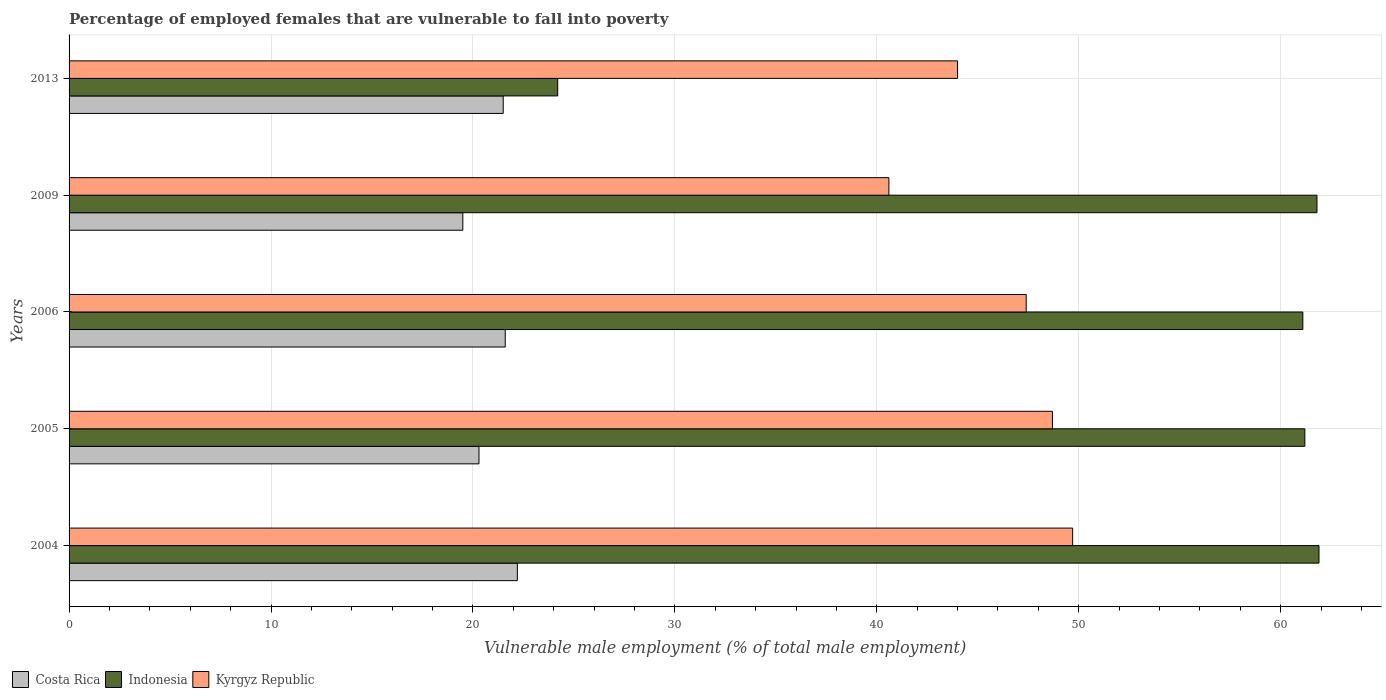How many different coloured bars are there?
Give a very brief answer. 3. Are the number of bars per tick equal to the number of legend labels?
Keep it short and to the point. Yes. What is the label of the 5th group of bars from the top?
Make the answer very short. 2004. What is the percentage of employed females who are vulnerable to fall into poverty in Costa Rica in 2013?
Your answer should be compact. 21.5. Across all years, what is the maximum percentage of employed females who are vulnerable to fall into poverty in Kyrgyz Republic?
Keep it short and to the point. 49.7. Across all years, what is the minimum percentage of employed females who are vulnerable to fall into poverty in Costa Rica?
Your answer should be very brief. 19.5. What is the total percentage of employed females who are vulnerable to fall into poverty in Costa Rica in the graph?
Offer a terse response. 105.1. What is the difference between the percentage of employed females who are vulnerable to fall into poverty in Costa Rica in 2004 and that in 2006?
Offer a terse response. 0.6. What is the difference between the percentage of employed females who are vulnerable to fall into poverty in Indonesia in 2006 and the percentage of employed females who are vulnerable to fall into poverty in Kyrgyz Republic in 2013?
Offer a terse response. 17.1. What is the average percentage of employed females who are vulnerable to fall into poverty in Costa Rica per year?
Ensure brevity in your answer.  21.02. In the year 2006, what is the difference between the percentage of employed females who are vulnerable to fall into poverty in Kyrgyz Republic and percentage of employed females who are vulnerable to fall into poverty in Indonesia?
Make the answer very short. -13.7. In how many years, is the percentage of employed females who are vulnerable to fall into poverty in Costa Rica greater than 2 %?
Your response must be concise. 5. What is the ratio of the percentage of employed females who are vulnerable to fall into poverty in Indonesia in 2005 to that in 2006?
Give a very brief answer. 1. Is the difference between the percentage of employed females who are vulnerable to fall into poverty in Kyrgyz Republic in 2004 and 2013 greater than the difference between the percentage of employed females who are vulnerable to fall into poverty in Indonesia in 2004 and 2013?
Provide a succinct answer. No. What is the difference between the highest and the second highest percentage of employed females who are vulnerable to fall into poverty in Costa Rica?
Offer a very short reply. 0.6. What is the difference between the highest and the lowest percentage of employed females who are vulnerable to fall into poverty in Indonesia?
Keep it short and to the point. 37.7. In how many years, is the percentage of employed females who are vulnerable to fall into poverty in Kyrgyz Republic greater than the average percentage of employed females who are vulnerable to fall into poverty in Kyrgyz Republic taken over all years?
Your answer should be very brief. 3. Is the sum of the percentage of employed females who are vulnerable to fall into poverty in Costa Rica in 2006 and 2013 greater than the maximum percentage of employed females who are vulnerable to fall into poverty in Indonesia across all years?
Your answer should be very brief. No. Is it the case that in every year, the sum of the percentage of employed females who are vulnerable to fall into poverty in Costa Rica and percentage of employed females who are vulnerable to fall into poverty in Kyrgyz Republic is greater than the percentage of employed females who are vulnerable to fall into poverty in Indonesia?
Your answer should be very brief. No. Are all the bars in the graph horizontal?
Keep it short and to the point. Yes. Does the graph contain any zero values?
Your response must be concise. No. Does the graph contain grids?
Make the answer very short. Yes. Where does the legend appear in the graph?
Your response must be concise. Bottom left. What is the title of the graph?
Provide a succinct answer. Percentage of employed females that are vulnerable to fall into poverty. What is the label or title of the X-axis?
Give a very brief answer. Vulnerable male employment (% of total male employment). What is the label or title of the Y-axis?
Provide a succinct answer. Years. What is the Vulnerable male employment (% of total male employment) of Costa Rica in 2004?
Your response must be concise. 22.2. What is the Vulnerable male employment (% of total male employment) in Indonesia in 2004?
Your response must be concise. 61.9. What is the Vulnerable male employment (% of total male employment) in Kyrgyz Republic in 2004?
Your answer should be compact. 49.7. What is the Vulnerable male employment (% of total male employment) of Costa Rica in 2005?
Keep it short and to the point. 20.3. What is the Vulnerable male employment (% of total male employment) of Indonesia in 2005?
Your answer should be compact. 61.2. What is the Vulnerable male employment (% of total male employment) in Kyrgyz Republic in 2005?
Your answer should be very brief. 48.7. What is the Vulnerable male employment (% of total male employment) in Costa Rica in 2006?
Ensure brevity in your answer.  21.6. What is the Vulnerable male employment (% of total male employment) in Indonesia in 2006?
Your answer should be compact. 61.1. What is the Vulnerable male employment (% of total male employment) in Kyrgyz Republic in 2006?
Your answer should be compact. 47.4. What is the Vulnerable male employment (% of total male employment) in Costa Rica in 2009?
Provide a succinct answer. 19.5. What is the Vulnerable male employment (% of total male employment) of Indonesia in 2009?
Provide a succinct answer. 61.8. What is the Vulnerable male employment (% of total male employment) of Kyrgyz Republic in 2009?
Provide a succinct answer. 40.6. What is the Vulnerable male employment (% of total male employment) in Indonesia in 2013?
Offer a very short reply. 24.2. What is the Vulnerable male employment (% of total male employment) of Kyrgyz Republic in 2013?
Make the answer very short. 44. Across all years, what is the maximum Vulnerable male employment (% of total male employment) in Costa Rica?
Offer a terse response. 22.2. Across all years, what is the maximum Vulnerable male employment (% of total male employment) of Indonesia?
Offer a very short reply. 61.9. Across all years, what is the maximum Vulnerable male employment (% of total male employment) of Kyrgyz Republic?
Provide a succinct answer. 49.7. Across all years, what is the minimum Vulnerable male employment (% of total male employment) in Indonesia?
Your answer should be compact. 24.2. Across all years, what is the minimum Vulnerable male employment (% of total male employment) in Kyrgyz Republic?
Offer a terse response. 40.6. What is the total Vulnerable male employment (% of total male employment) of Costa Rica in the graph?
Your answer should be compact. 105.1. What is the total Vulnerable male employment (% of total male employment) in Indonesia in the graph?
Offer a very short reply. 270.2. What is the total Vulnerable male employment (% of total male employment) in Kyrgyz Republic in the graph?
Your answer should be compact. 230.4. What is the difference between the Vulnerable male employment (% of total male employment) in Indonesia in 2004 and that in 2005?
Make the answer very short. 0.7. What is the difference between the Vulnerable male employment (% of total male employment) in Costa Rica in 2004 and that in 2006?
Your answer should be very brief. 0.6. What is the difference between the Vulnerable male employment (% of total male employment) in Kyrgyz Republic in 2004 and that in 2006?
Give a very brief answer. 2.3. What is the difference between the Vulnerable male employment (% of total male employment) in Costa Rica in 2004 and that in 2009?
Offer a very short reply. 2.7. What is the difference between the Vulnerable male employment (% of total male employment) in Indonesia in 2004 and that in 2009?
Provide a succinct answer. 0.1. What is the difference between the Vulnerable male employment (% of total male employment) in Costa Rica in 2004 and that in 2013?
Provide a succinct answer. 0.7. What is the difference between the Vulnerable male employment (% of total male employment) in Indonesia in 2004 and that in 2013?
Make the answer very short. 37.7. What is the difference between the Vulnerable male employment (% of total male employment) of Kyrgyz Republic in 2004 and that in 2013?
Provide a short and direct response. 5.7. What is the difference between the Vulnerable male employment (% of total male employment) in Indonesia in 2005 and that in 2006?
Ensure brevity in your answer.  0.1. What is the difference between the Vulnerable male employment (% of total male employment) in Kyrgyz Republic in 2005 and that in 2009?
Provide a short and direct response. 8.1. What is the difference between the Vulnerable male employment (% of total male employment) of Indonesia in 2005 and that in 2013?
Ensure brevity in your answer.  37. What is the difference between the Vulnerable male employment (% of total male employment) in Indonesia in 2006 and that in 2009?
Your response must be concise. -0.7. What is the difference between the Vulnerable male employment (% of total male employment) in Costa Rica in 2006 and that in 2013?
Keep it short and to the point. 0.1. What is the difference between the Vulnerable male employment (% of total male employment) in Indonesia in 2006 and that in 2013?
Make the answer very short. 36.9. What is the difference between the Vulnerable male employment (% of total male employment) in Kyrgyz Republic in 2006 and that in 2013?
Provide a short and direct response. 3.4. What is the difference between the Vulnerable male employment (% of total male employment) in Costa Rica in 2009 and that in 2013?
Give a very brief answer. -2. What is the difference between the Vulnerable male employment (% of total male employment) in Indonesia in 2009 and that in 2013?
Offer a very short reply. 37.6. What is the difference between the Vulnerable male employment (% of total male employment) in Costa Rica in 2004 and the Vulnerable male employment (% of total male employment) in Indonesia in 2005?
Your response must be concise. -39. What is the difference between the Vulnerable male employment (% of total male employment) in Costa Rica in 2004 and the Vulnerable male employment (% of total male employment) in Kyrgyz Republic in 2005?
Your answer should be compact. -26.5. What is the difference between the Vulnerable male employment (% of total male employment) in Indonesia in 2004 and the Vulnerable male employment (% of total male employment) in Kyrgyz Republic in 2005?
Your answer should be compact. 13.2. What is the difference between the Vulnerable male employment (% of total male employment) in Costa Rica in 2004 and the Vulnerable male employment (% of total male employment) in Indonesia in 2006?
Your answer should be very brief. -38.9. What is the difference between the Vulnerable male employment (% of total male employment) of Costa Rica in 2004 and the Vulnerable male employment (% of total male employment) of Kyrgyz Republic in 2006?
Provide a succinct answer. -25.2. What is the difference between the Vulnerable male employment (% of total male employment) in Indonesia in 2004 and the Vulnerable male employment (% of total male employment) in Kyrgyz Republic in 2006?
Provide a short and direct response. 14.5. What is the difference between the Vulnerable male employment (% of total male employment) of Costa Rica in 2004 and the Vulnerable male employment (% of total male employment) of Indonesia in 2009?
Give a very brief answer. -39.6. What is the difference between the Vulnerable male employment (% of total male employment) in Costa Rica in 2004 and the Vulnerable male employment (% of total male employment) in Kyrgyz Republic in 2009?
Make the answer very short. -18.4. What is the difference between the Vulnerable male employment (% of total male employment) of Indonesia in 2004 and the Vulnerable male employment (% of total male employment) of Kyrgyz Republic in 2009?
Offer a very short reply. 21.3. What is the difference between the Vulnerable male employment (% of total male employment) of Costa Rica in 2004 and the Vulnerable male employment (% of total male employment) of Kyrgyz Republic in 2013?
Your answer should be compact. -21.8. What is the difference between the Vulnerable male employment (% of total male employment) of Costa Rica in 2005 and the Vulnerable male employment (% of total male employment) of Indonesia in 2006?
Offer a terse response. -40.8. What is the difference between the Vulnerable male employment (% of total male employment) of Costa Rica in 2005 and the Vulnerable male employment (% of total male employment) of Kyrgyz Republic in 2006?
Give a very brief answer. -27.1. What is the difference between the Vulnerable male employment (% of total male employment) in Costa Rica in 2005 and the Vulnerable male employment (% of total male employment) in Indonesia in 2009?
Make the answer very short. -41.5. What is the difference between the Vulnerable male employment (% of total male employment) of Costa Rica in 2005 and the Vulnerable male employment (% of total male employment) of Kyrgyz Republic in 2009?
Make the answer very short. -20.3. What is the difference between the Vulnerable male employment (% of total male employment) in Indonesia in 2005 and the Vulnerable male employment (% of total male employment) in Kyrgyz Republic in 2009?
Your response must be concise. 20.6. What is the difference between the Vulnerable male employment (% of total male employment) in Costa Rica in 2005 and the Vulnerable male employment (% of total male employment) in Indonesia in 2013?
Your answer should be very brief. -3.9. What is the difference between the Vulnerable male employment (% of total male employment) in Costa Rica in 2005 and the Vulnerable male employment (% of total male employment) in Kyrgyz Republic in 2013?
Your response must be concise. -23.7. What is the difference between the Vulnerable male employment (% of total male employment) in Indonesia in 2005 and the Vulnerable male employment (% of total male employment) in Kyrgyz Republic in 2013?
Keep it short and to the point. 17.2. What is the difference between the Vulnerable male employment (% of total male employment) of Costa Rica in 2006 and the Vulnerable male employment (% of total male employment) of Indonesia in 2009?
Offer a very short reply. -40.2. What is the difference between the Vulnerable male employment (% of total male employment) of Costa Rica in 2006 and the Vulnerable male employment (% of total male employment) of Kyrgyz Republic in 2013?
Make the answer very short. -22.4. What is the difference between the Vulnerable male employment (% of total male employment) in Indonesia in 2006 and the Vulnerable male employment (% of total male employment) in Kyrgyz Republic in 2013?
Keep it short and to the point. 17.1. What is the difference between the Vulnerable male employment (% of total male employment) in Costa Rica in 2009 and the Vulnerable male employment (% of total male employment) in Indonesia in 2013?
Your response must be concise. -4.7. What is the difference between the Vulnerable male employment (% of total male employment) in Costa Rica in 2009 and the Vulnerable male employment (% of total male employment) in Kyrgyz Republic in 2013?
Provide a short and direct response. -24.5. What is the average Vulnerable male employment (% of total male employment) of Costa Rica per year?
Your response must be concise. 21.02. What is the average Vulnerable male employment (% of total male employment) of Indonesia per year?
Offer a very short reply. 54.04. What is the average Vulnerable male employment (% of total male employment) in Kyrgyz Republic per year?
Keep it short and to the point. 46.08. In the year 2004, what is the difference between the Vulnerable male employment (% of total male employment) of Costa Rica and Vulnerable male employment (% of total male employment) of Indonesia?
Provide a short and direct response. -39.7. In the year 2004, what is the difference between the Vulnerable male employment (% of total male employment) in Costa Rica and Vulnerable male employment (% of total male employment) in Kyrgyz Republic?
Offer a very short reply. -27.5. In the year 2004, what is the difference between the Vulnerable male employment (% of total male employment) of Indonesia and Vulnerable male employment (% of total male employment) of Kyrgyz Republic?
Offer a terse response. 12.2. In the year 2005, what is the difference between the Vulnerable male employment (% of total male employment) in Costa Rica and Vulnerable male employment (% of total male employment) in Indonesia?
Your answer should be very brief. -40.9. In the year 2005, what is the difference between the Vulnerable male employment (% of total male employment) in Costa Rica and Vulnerable male employment (% of total male employment) in Kyrgyz Republic?
Provide a short and direct response. -28.4. In the year 2006, what is the difference between the Vulnerable male employment (% of total male employment) of Costa Rica and Vulnerable male employment (% of total male employment) of Indonesia?
Your answer should be compact. -39.5. In the year 2006, what is the difference between the Vulnerable male employment (% of total male employment) of Costa Rica and Vulnerable male employment (% of total male employment) of Kyrgyz Republic?
Give a very brief answer. -25.8. In the year 2009, what is the difference between the Vulnerable male employment (% of total male employment) of Costa Rica and Vulnerable male employment (% of total male employment) of Indonesia?
Your response must be concise. -42.3. In the year 2009, what is the difference between the Vulnerable male employment (% of total male employment) of Costa Rica and Vulnerable male employment (% of total male employment) of Kyrgyz Republic?
Provide a succinct answer. -21.1. In the year 2009, what is the difference between the Vulnerable male employment (% of total male employment) of Indonesia and Vulnerable male employment (% of total male employment) of Kyrgyz Republic?
Keep it short and to the point. 21.2. In the year 2013, what is the difference between the Vulnerable male employment (% of total male employment) of Costa Rica and Vulnerable male employment (% of total male employment) of Indonesia?
Offer a very short reply. -2.7. In the year 2013, what is the difference between the Vulnerable male employment (% of total male employment) of Costa Rica and Vulnerable male employment (% of total male employment) of Kyrgyz Republic?
Your answer should be very brief. -22.5. In the year 2013, what is the difference between the Vulnerable male employment (% of total male employment) in Indonesia and Vulnerable male employment (% of total male employment) in Kyrgyz Republic?
Make the answer very short. -19.8. What is the ratio of the Vulnerable male employment (% of total male employment) of Costa Rica in 2004 to that in 2005?
Provide a succinct answer. 1.09. What is the ratio of the Vulnerable male employment (% of total male employment) in Indonesia in 2004 to that in 2005?
Your answer should be very brief. 1.01. What is the ratio of the Vulnerable male employment (% of total male employment) in Kyrgyz Republic in 2004 to that in 2005?
Your answer should be compact. 1.02. What is the ratio of the Vulnerable male employment (% of total male employment) in Costa Rica in 2004 to that in 2006?
Make the answer very short. 1.03. What is the ratio of the Vulnerable male employment (% of total male employment) in Indonesia in 2004 to that in 2006?
Your answer should be compact. 1.01. What is the ratio of the Vulnerable male employment (% of total male employment) of Kyrgyz Republic in 2004 to that in 2006?
Offer a terse response. 1.05. What is the ratio of the Vulnerable male employment (% of total male employment) in Costa Rica in 2004 to that in 2009?
Your answer should be very brief. 1.14. What is the ratio of the Vulnerable male employment (% of total male employment) of Kyrgyz Republic in 2004 to that in 2009?
Your response must be concise. 1.22. What is the ratio of the Vulnerable male employment (% of total male employment) of Costa Rica in 2004 to that in 2013?
Offer a very short reply. 1.03. What is the ratio of the Vulnerable male employment (% of total male employment) in Indonesia in 2004 to that in 2013?
Your answer should be compact. 2.56. What is the ratio of the Vulnerable male employment (% of total male employment) of Kyrgyz Republic in 2004 to that in 2013?
Ensure brevity in your answer.  1.13. What is the ratio of the Vulnerable male employment (% of total male employment) of Costa Rica in 2005 to that in 2006?
Keep it short and to the point. 0.94. What is the ratio of the Vulnerable male employment (% of total male employment) in Kyrgyz Republic in 2005 to that in 2006?
Your answer should be compact. 1.03. What is the ratio of the Vulnerable male employment (% of total male employment) of Costa Rica in 2005 to that in 2009?
Your answer should be compact. 1.04. What is the ratio of the Vulnerable male employment (% of total male employment) in Indonesia in 2005 to that in 2009?
Ensure brevity in your answer.  0.99. What is the ratio of the Vulnerable male employment (% of total male employment) in Kyrgyz Republic in 2005 to that in 2009?
Offer a terse response. 1.2. What is the ratio of the Vulnerable male employment (% of total male employment) of Costa Rica in 2005 to that in 2013?
Make the answer very short. 0.94. What is the ratio of the Vulnerable male employment (% of total male employment) in Indonesia in 2005 to that in 2013?
Keep it short and to the point. 2.53. What is the ratio of the Vulnerable male employment (% of total male employment) of Kyrgyz Republic in 2005 to that in 2013?
Make the answer very short. 1.11. What is the ratio of the Vulnerable male employment (% of total male employment) of Costa Rica in 2006 to that in 2009?
Offer a terse response. 1.11. What is the ratio of the Vulnerable male employment (% of total male employment) in Indonesia in 2006 to that in 2009?
Ensure brevity in your answer.  0.99. What is the ratio of the Vulnerable male employment (% of total male employment) of Kyrgyz Republic in 2006 to that in 2009?
Your answer should be compact. 1.17. What is the ratio of the Vulnerable male employment (% of total male employment) of Costa Rica in 2006 to that in 2013?
Your answer should be very brief. 1. What is the ratio of the Vulnerable male employment (% of total male employment) of Indonesia in 2006 to that in 2013?
Provide a short and direct response. 2.52. What is the ratio of the Vulnerable male employment (% of total male employment) in Kyrgyz Republic in 2006 to that in 2013?
Provide a succinct answer. 1.08. What is the ratio of the Vulnerable male employment (% of total male employment) in Costa Rica in 2009 to that in 2013?
Your answer should be compact. 0.91. What is the ratio of the Vulnerable male employment (% of total male employment) in Indonesia in 2009 to that in 2013?
Provide a short and direct response. 2.55. What is the ratio of the Vulnerable male employment (% of total male employment) of Kyrgyz Republic in 2009 to that in 2013?
Give a very brief answer. 0.92. What is the difference between the highest and the second highest Vulnerable male employment (% of total male employment) in Costa Rica?
Offer a very short reply. 0.6. What is the difference between the highest and the second highest Vulnerable male employment (% of total male employment) of Indonesia?
Provide a succinct answer. 0.1. What is the difference between the highest and the lowest Vulnerable male employment (% of total male employment) in Costa Rica?
Make the answer very short. 2.7. What is the difference between the highest and the lowest Vulnerable male employment (% of total male employment) in Indonesia?
Provide a short and direct response. 37.7. What is the difference between the highest and the lowest Vulnerable male employment (% of total male employment) of Kyrgyz Republic?
Make the answer very short. 9.1. 